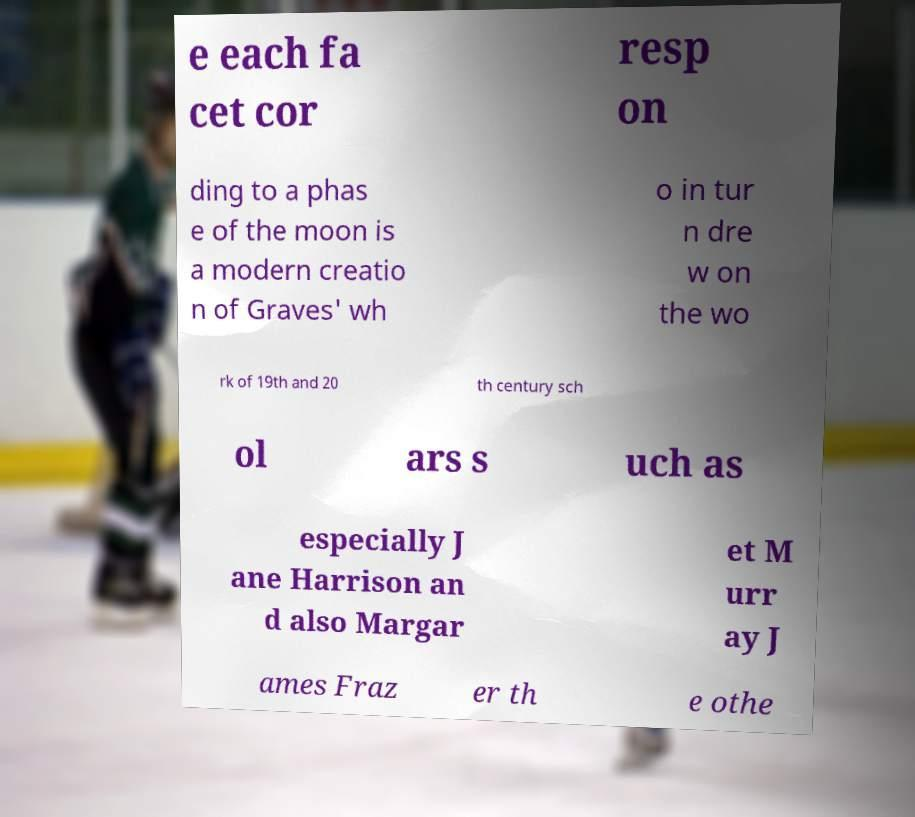Can you accurately transcribe the text from the provided image for me? e each fa cet cor resp on ding to a phas e of the moon is a modern creatio n of Graves' wh o in tur n dre w on the wo rk of 19th and 20 th century sch ol ars s uch as especially J ane Harrison an d also Margar et M urr ay J ames Fraz er th e othe 